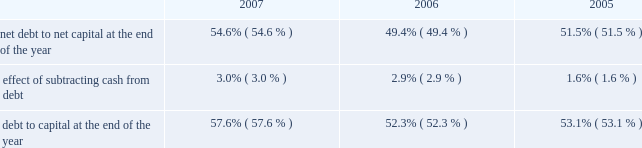E nt e r g y c o r p o r a t i o n a n d s u b s i d i a r i e s 2 0 0 7 n an increase of $ 16 million in fossil operating costs due to the purchase of the attala plant in january 2006 and the perryville plant coming online in july 2005 ; n an increase of $ 12 million related to storm reserves .
This increase does not include costs associated with hurricanes katrina and rita ; and n an increase of $ 12 million due to a return to normal expense patterns in 2006 versus the deferral or capitalization of storm costs in 2005 .
Other operation and maintenance expenses increased for non- utility nuclear from $ 588 million in 2005 to $ 637 million in 2006 primarily due to the timing of refueling outages , increased benefit and insurance costs , and increased nrc fees .
Taxes other than income taxes taxes other than income taxes increased for the utility from $ 322 million in 2005 to $ 361 million in 2006 primarily due to an increase in city franchise taxes in arkansas due to a change in 2006 in the accounting for city franchise tax revenues as directed by the apsc .
The change results in an increase in taxes other than income taxes with a corresponding increase in rider revenue , resulting in no effect on net income .
Also contributing to the increase was higher franchise tax expense at entergy gulf states , inc .
As a result of higher gross revenues in 2006 and a customer refund in 2005 .
Other income other income increased for the utility from $ 111 million in 2005 to $ 156 million in 2006 primarily due to carrying charges recorded on storm restoration costs .
Other income increased for non-utility nuclear primarily due to miscellaneous income of $ 27 million ( $ 16.6 million net-of-tax ) resulting from a reduction in the decommissioning liability for a plant as a result of a revised decommissioning cost study and changes in assumptions regarding the timing of when decommissioning of a plant will begin .
Other income increased for parent & other primarily due to a gain related to its entergy-koch investment of approximately $ 55 million ( net-of-tax ) in the fourth quarter of 2006 .
In 2004 , entergy-koch sold its energy trading and pipeline businesses to third parties .
At that time , entergy received $ 862 million of the sales proceeds in the form of a cash distribution by entergy-koch .
Due to the november 2006 expiration of contingencies on the sale of entergy-koch 2019s trading business , and the corresponding release to entergy-koch of sales proceeds held in escrow , entergy received additional cash distributions of approximately $ 163 million during the fourth quarter of 2006 and recorded a gain of approximately $ 55 million ( net-of-tax ) .
Entergy expects future cash distributions upon liquidation of the partnership will be less than $ 35 million .
Interest charges interest charges increased for the utility and parent & other primarily due to additional borrowing to fund the significant storm restoration costs associated with hurricanes katrina and rita .
Discontinued operations in april 2006 , entergy sold the retail electric portion of the competitive retail services business operating in the electric reliability council of texas ( ercot ) region of texas , and now reports this portion of the business as a discontinued operation .
Earnings for 2005 were negatively affected by $ 44.8 million ( net-of-tax ) of discontinued operations due to the planned sale .
This amount includes a net charge of $ 25.8 million ( net-of-tax ) related to the impairment reserve for the remaining net book value of the competitive retail services business 2019 information technology systems .
Results for 2006 include an $ 11.1 million gain ( net-of-tax ) on the sale of the retail electric portion of the competitive retail services business operating in the ercot region of texas .
Income taxes the effective income tax rates for 2006 and 2005 were 27.6% ( 27.6 % ) and 36.6% ( 36.6 % ) , respectively .
The lower effective income tax rate in 2006 is primarily due to tax benefits , net of reserves , resulting from the tax capital loss recognized in connection with the liquidation of entergy power international holdings , entergy 2019s holding company for entergy-koch .
Also contributing to the lower rate for 2006 is an irs audit settlement that allowed entergy to release from its tax reserves all settled issues relating to 1996-1998 audit cycle .
See note 3 to the financial statements for a reconciliation of the federal statutory rate of 35.0% ( 35.0 % ) to the effective income tax rates , and for additional discussion regarding income taxes .
Liquidity and capital resources this section discusses entergy 2019s capital structure , capital spending plans and other uses of capital , sources of capital , and the cash flow activity presented in the cash flow statement .
Capital structure entergy 2019s capitalization is balanced between equity and debt , as shown in the table .
The increase in the debt to capital percentage from 2006 to 2007 is primarily the result of additional borrowings under entergy corporation 2019s revolving credit facility , along with a decrease in shareholders 2019 equity primarily due to repurchases of common stock .
This increase in the debt to capital percentage is in line with entergy 2019s financial and risk management aspirations .
The decrease in the debt to capital percentage from 2005 to 2006 is the result of an increase in shareholders 2019 equity , primarily due to an increase in retained earnings , partially offset by repurchases of common stock. .
Net debt consists of debt less cash and cash equivalents .
Debt consists of notes payable , capital lease obligations , preferred stock with sinking fund , and long-term debt , including the currently maturing portion .
Capital consists of debt , shareholders 2019 equity , and preferred stock without sinking fund .
Net capital consists of capital less cash and cash equivalents .
Entergy uses the net debt to net capital ratio in analyzing its financial condition and believes it provides useful information to its investors and creditors in evaluating entergy 2019s financial condition .
M an ag e ment 2019s f i n anc ial d i scuss ion an d an alys is co n t i n u e d .
What was the percent of the increase in other income other income for the utility from 2005 to 2006? 
Computations: ((156 - 111) / 111)
Answer: 0.40541. 